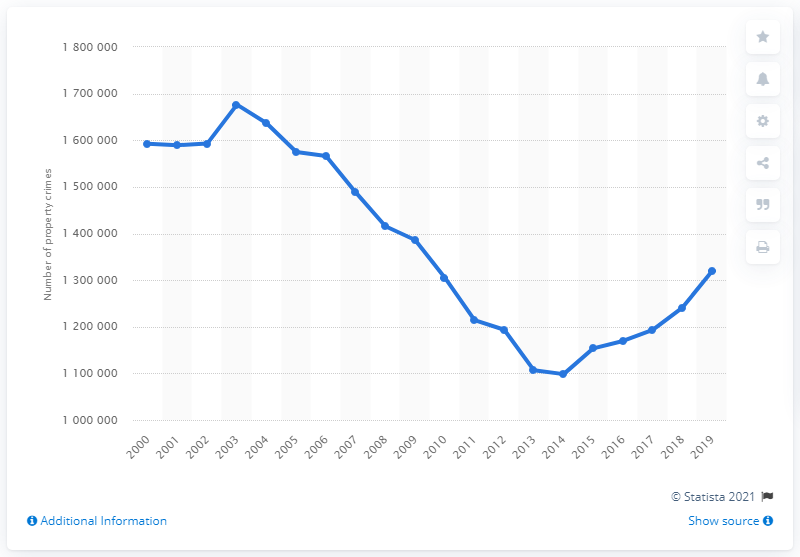List a handful of essential elements in this visual. In 2019, there were a reported 131,956 property crimes in Canada. 